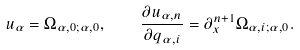Convert formula to latex. <formula><loc_0><loc_0><loc_500><loc_500>u _ { \alpha } = \Omega _ { \alpha , 0 ; \alpha , 0 } , \quad \frac { \partial u _ { \alpha , n } } { \partial q _ { \alpha , i } } = \partial _ { x } ^ { n + 1 } \Omega _ { \alpha , i ; \alpha , 0 } .</formula> 